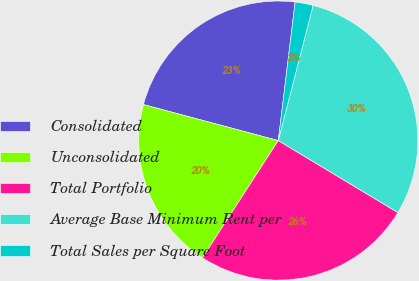Convert chart to OTSL. <chart><loc_0><loc_0><loc_500><loc_500><pie_chart><fcel>Consolidated<fcel>Unconsolidated<fcel>Total Portfolio<fcel>Average Base Minimum Rent per<fcel>Total Sales per Square Foot<nl><fcel>22.77%<fcel>20.02%<fcel>25.52%<fcel>29.61%<fcel>2.09%<nl></chart> 